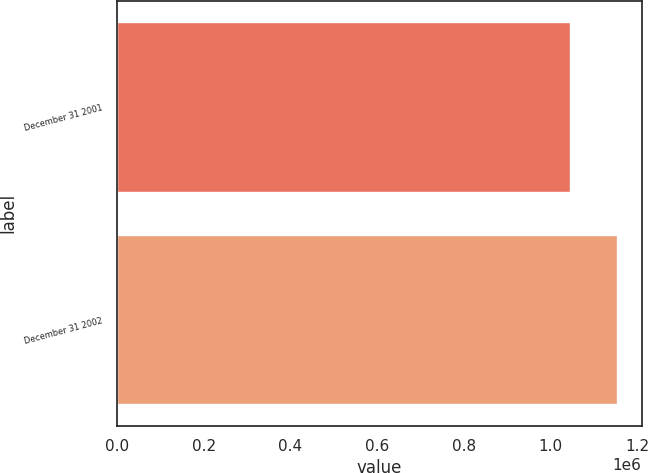<chart> <loc_0><loc_0><loc_500><loc_500><bar_chart><fcel>December 31 2001<fcel>December 31 2002<nl><fcel>1.04436e+06<fcel>1.15208e+06<nl></chart> 